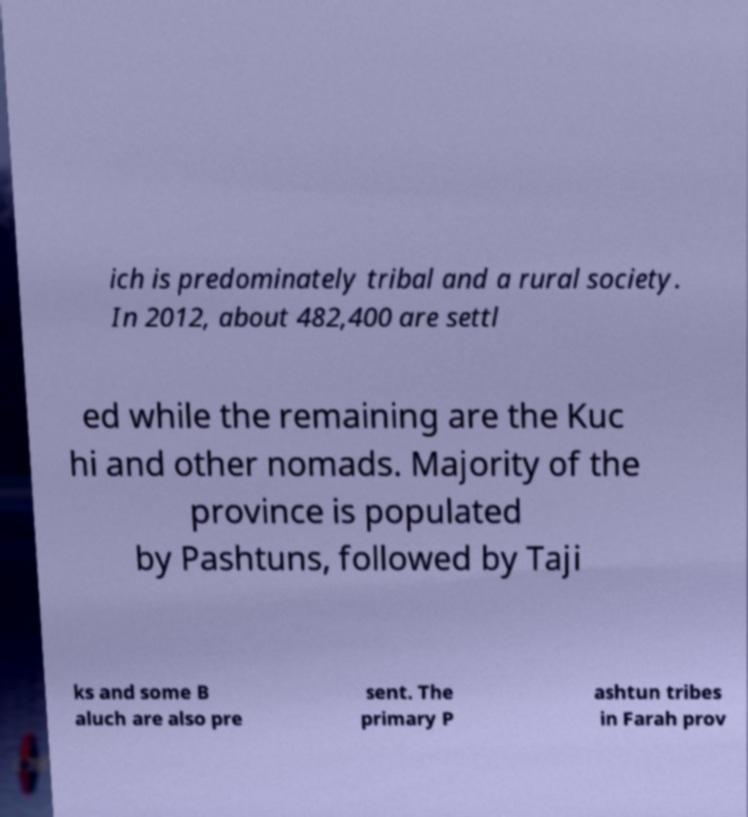Could you extract and type out the text from this image? ich is predominately tribal and a rural society. In 2012, about 482,400 are settl ed while the remaining are the Kuc hi and other nomads. Majority of the province is populated by Pashtuns, followed by Taji ks and some B aluch are also pre sent. The primary P ashtun tribes in Farah prov 